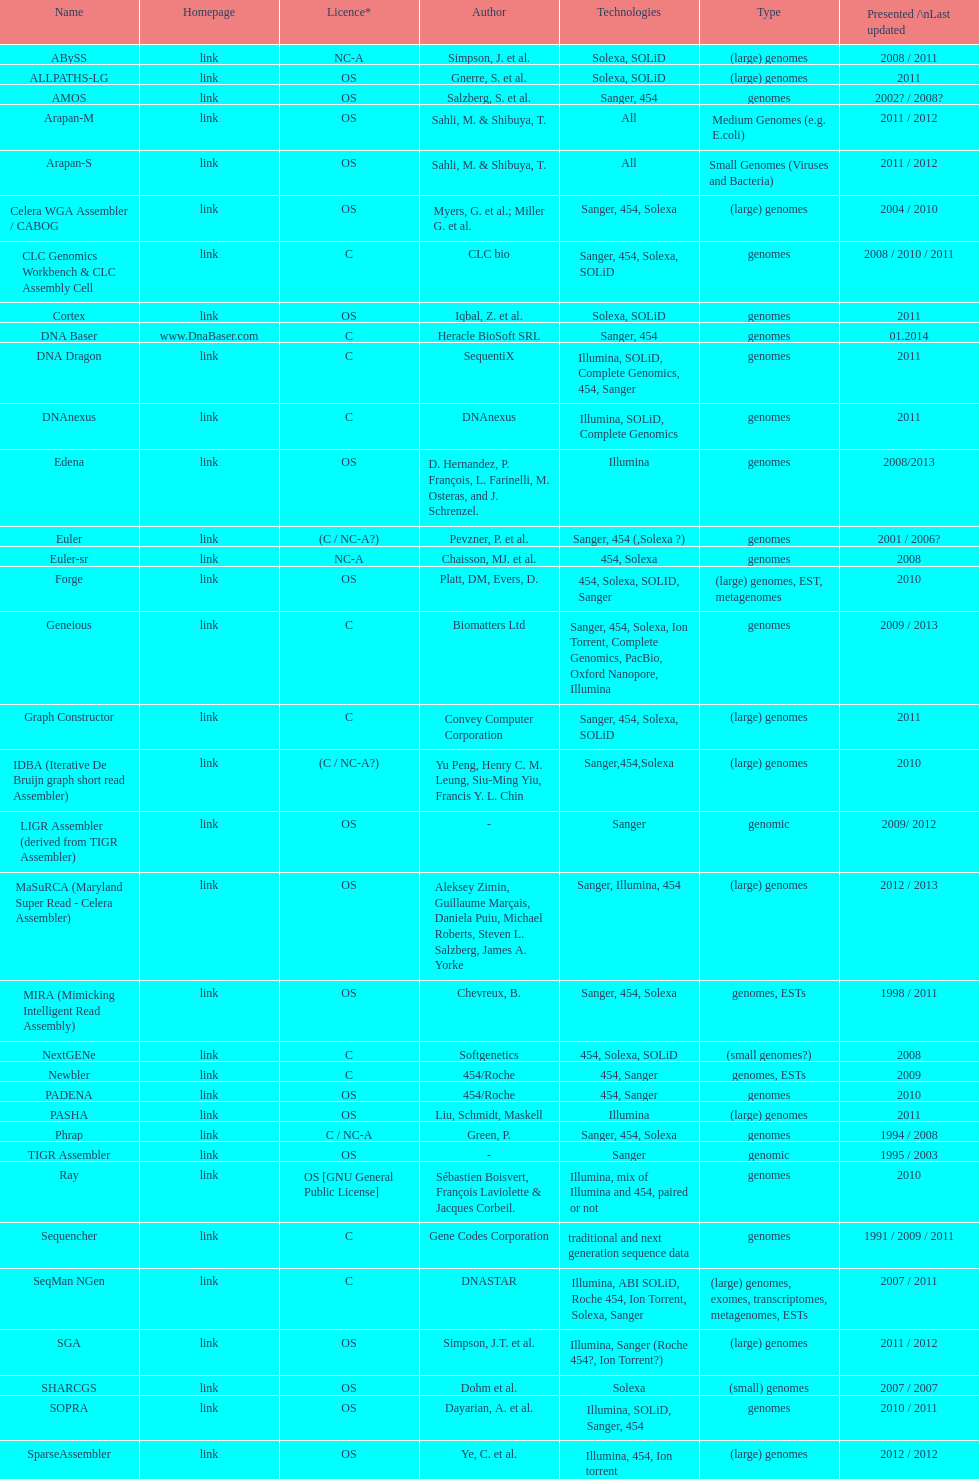What is the overall count of assemblers that support small genomes type technologies? 9. 